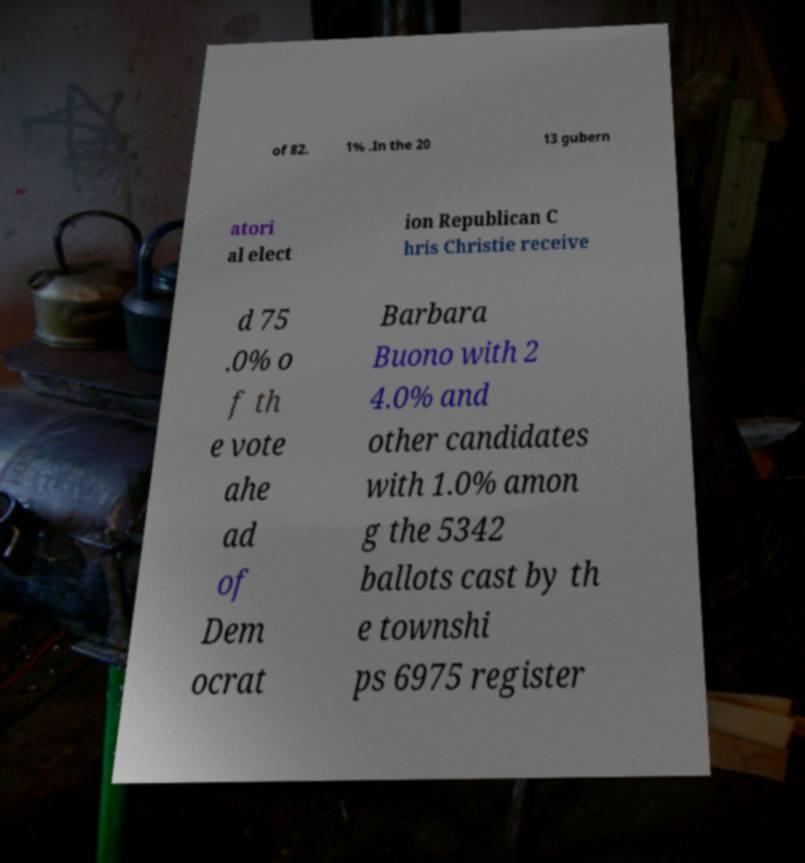There's text embedded in this image that I need extracted. Can you transcribe it verbatim? of 82. 1% .In the 20 13 gubern atori al elect ion Republican C hris Christie receive d 75 .0% o f th e vote ahe ad of Dem ocrat Barbara Buono with 2 4.0% and other candidates with 1.0% amon g the 5342 ballots cast by th e townshi ps 6975 register 